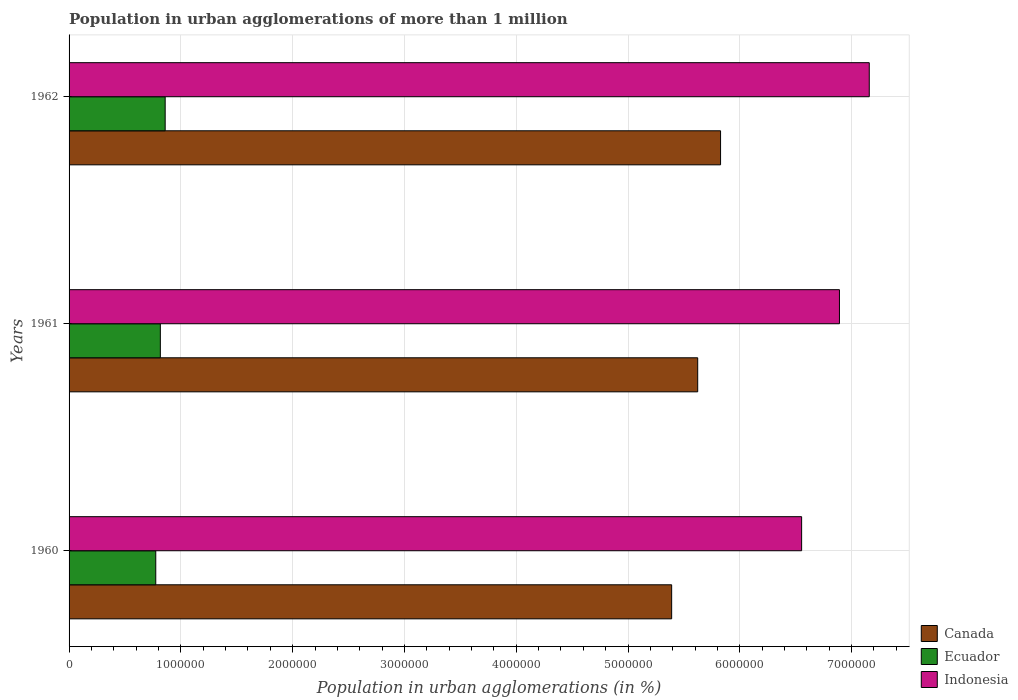How many different coloured bars are there?
Make the answer very short. 3. How many groups of bars are there?
Offer a terse response. 3. What is the label of the 1st group of bars from the top?
Offer a very short reply. 1962. In how many cases, is the number of bars for a given year not equal to the number of legend labels?
Your answer should be very brief. 0. What is the population in urban agglomerations in Indonesia in 1961?
Provide a succinct answer. 6.89e+06. Across all years, what is the maximum population in urban agglomerations in Canada?
Offer a very short reply. 5.83e+06. Across all years, what is the minimum population in urban agglomerations in Ecuador?
Offer a terse response. 7.76e+05. What is the total population in urban agglomerations in Ecuador in the graph?
Your answer should be very brief. 2.45e+06. What is the difference between the population in urban agglomerations in Canada in 1961 and that in 1962?
Your answer should be very brief. -2.04e+05. What is the difference between the population in urban agglomerations in Indonesia in 1962 and the population in urban agglomerations in Canada in 1960?
Make the answer very short. 1.77e+06. What is the average population in urban agglomerations in Indonesia per year?
Make the answer very short. 6.87e+06. In the year 1962, what is the difference between the population in urban agglomerations in Canada and population in urban agglomerations in Ecuador?
Your response must be concise. 4.97e+06. What is the ratio of the population in urban agglomerations in Indonesia in 1960 to that in 1961?
Ensure brevity in your answer.  0.95. What is the difference between the highest and the second highest population in urban agglomerations in Ecuador?
Ensure brevity in your answer.  4.32e+04. What is the difference between the highest and the lowest population in urban agglomerations in Indonesia?
Provide a short and direct response. 6.05e+05. In how many years, is the population in urban agglomerations in Indonesia greater than the average population in urban agglomerations in Indonesia taken over all years?
Provide a short and direct response. 2. How many bars are there?
Keep it short and to the point. 9. Are all the bars in the graph horizontal?
Give a very brief answer. Yes. How many years are there in the graph?
Your response must be concise. 3. What is the difference between two consecutive major ticks on the X-axis?
Give a very brief answer. 1.00e+06. Does the graph contain any zero values?
Provide a short and direct response. No. Does the graph contain grids?
Your answer should be compact. Yes. How many legend labels are there?
Offer a very short reply. 3. How are the legend labels stacked?
Keep it short and to the point. Vertical. What is the title of the graph?
Provide a succinct answer. Population in urban agglomerations of more than 1 million. Does "Bulgaria" appear as one of the legend labels in the graph?
Your response must be concise. No. What is the label or title of the X-axis?
Offer a very short reply. Population in urban agglomerations (in %). What is the Population in urban agglomerations (in %) in Canada in 1960?
Offer a very short reply. 5.39e+06. What is the Population in urban agglomerations (in %) in Ecuador in 1960?
Keep it short and to the point. 7.76e+05. What is the Population in urban agglomerations (in %) of Indonesia in 1960?
Your answer should be compact. 6.55e+06. What is the Population in urban agglomerations (in %) of Canada in 1961?
Ensure brevity in your answer.  5.62e+06. What is the Population in urban agglomerations (in %) of Ecuador in 1961?
Offer a terse response. 8.16e+05. What is the Population in urban agglomerations (in %) of Indonesia in 1961?
Ensure brevity in your answer.  6.89e+06. What is the Population in urban agglomerations (in %) in Canada in 1962?
Your answer should be very brief. 5.83e+06. What is the Population in urban agglomerations (in %) in Ecuador in 1962?
Offer a terse response. 8.60e+05. What is the Population in urban agglomerations (in %) in Indonesia in 1962?
Make the answer very short. 7.16e+06. Across all years, what is the maximum Population in urban agglomerations (in %) in Canada?
Give a very brief answer. 5.83e+06. Across all years, what is the maximum Population in urban agglomerations (in %) in Ecuador?
Offer a very short reply. 8.60e+05. Across all years, what is the maximum Population in urban agglomerations (in %) in Indonesia?
Provide a succinct answer. 7.16e+06. Across all years, what is the minimum Population in urban agglomerations (in %) in Canada?
Make the answer very short. 5.39e+06. Across all years, what is the minimum Population in urban agglomerations (in %) in Ecuador?
Ensure brevity in your answer.  7.76e+05. Across all years, what is the minimum Population in urban agglomerations (in %) in Indonesia?
Keep it short and to the point. 6.55e+06. What is the total Population in urban agglomerations (in %) in Canada in the graph?
Provide a succinct answer. 1.68e+07. What is the total Population in urban agglomerations (in %) of Ecuador in the graph?
Your answer should be very brief. 2.45e+06. What is the total Population in urban agglomerations (in %) in Indonesia in the graph?
Ensure brevity in your answer.  2.06e+07. What is the difference between the Population in urban agglomerations (in %) in Canada in 1960 and that in 1961?
Provide a short and direct response. -2.33e+05. What is the difference between the Population in urban agglomerations (in %) in Ecuador in 1960 and that in 1961?
Your answer should be compact. -4.09e+04. What is the difference between the Population in urban agglomerations (in %) of Indonesia in 1960 and that in 1961?
Provide a short and direct response. -3.38e+05. What is the difference between the Population in urban agglomerations (in %) of Canada in 1960 and that in 1962?
Give a very brief answer. -4.37e+05. What is the difference between the Population in urban agglomerations (in %) in Ecuador in 1960 and that in 1962?
Provide a succinct answer. -8.41e+04. What is the difference between the Population in urban agglomerations (in %) of Indonesia in 1960 and that in 1962?
Your answer should be very brief. -6.05e+05. What is the difference between the Population in urban agglomerations (in %) of Canada in 1961 and that in 1962?
Make the answer very short. -2.04e+05. What is the difference between the Population in urban agglomerations (in %) of Ecuador in 1961 and that in 1962?
Provide a succinct answer. -4.32e+04. What is the difference between the Population in urban agglomerations (in %) of Indonesia in 1961 and that in 1962?
Keep it short and to the point. -2.67e+05. What is the difference between the Population in urban agglomerations (in %) of Canada in 1960 and the Population in urban agglomerations (in %) of Ecuador in 1961?
Give a very brief answer. 4.57e+06. What is the difference between the Population in urban agglomerations (in %) in Canada in 1960 and the Population in urban agglomerations (in %) in Indonesia in 1961?
Your answer should be compact. -1.50e+06. What is the difference between the Population in urban agglomerations (in %) in Ecuador in 1960 and the Population in urban agglomerations (in %) in Indonesia in 1961?
Keep it short and to the point. -6.12e+06. What is the difference between the Population in urban agglomerations (in %) of Canada in 1960 and the Population in urban agglomerations (in %) of Ecuador in 1962?
Keep it short and to the point. 4.53e+06. What is the difference between the Population in urban agglomerations (in %) in Canada in 1960 and the Population in urban agglomerations (in %) in Indonesia in 1962?
Give a very brief answer. -1.77e+06. What is the difference between the Population in urban agglomerations (in %) in Ecuador in 1960 and the Population in urban agglomerations (in %) in Indonesia in 1962?
Your response must be concise. -6.38e+06. What is the difference between the Population in urban agglomerations (in %) of Canada in 1961 and the Population in urban agglomerations (in %) of Ecuador in 1962?
Provide a succinct answer. 4.76e+06. What is the difference between the Population in urban agglomerations (in %) in Canada in 1961 and the Population in urban agglomerations (in %) in Indonesia in 1962?
Provide a short and direct response. -1.53e+06. What is the difference between the Population in urban agglomerations (in %) in Ecuador in 1961 and the Population in urban agglomerations (in %) in Indonesia in 1962?
Offer a terse response. -6.34e+06. What is the average Population in urban agglomerations (in %) of Canada per year?
Make the answer very short. 5.61e+06. What is the average Population in urban agglomerations (in %) of Ecuador per year?
Offer a terse response. 8.17e+05. What is the average Population in urban agglomerations (in %) in Indonesia per year?
Your answer should be very brief. 6.87e+06. In the year 1960, what is the difference between the Population in urban agglomerations (in %) in Canada and Population in urban agglomerations (in %) in Ecuador?
Provide a short and direct response. 4.61e+06. In the year 1960, what is the difference between the Population in urban agglomerations (in %) in Canada and Population in urban agglomerations (in %) in Indonesia?
Provide a short and direct response. -1.16e+06. In the year 1960, what is the difference between the Population in urban agglomerations (in %) in Ecuador and Population in urban agglomerations (in %) in Indonesia?
Your answer should be very brief. -5.78e+06. In the year 1961, what is the difference between the Population in urban agglomerations (in %) of Canada and Population in urban agglomerations (in %) of Ecuador?
Ensure brevity in your answer.  4.81e+06. In the year 1961, what is the difference between the Population in urban agglomerations (in %) of Canada and Population in urban agglomerations (in %) of Indonesia?
Your response must be concise. -1.27e+06. In the year 1961, what is the difference between the Population in urban agglomerations (in %) in Ecuador and Population in urban agglomerations (in %) in Indonesia?
Make the answer very short. -6.07e+06. In the year 1962, what is the difference between the Population in urban agglomerations (in %) of Canada and Population in urban agglomerations (in %) of Ecuador?
Your response must be concise. 4.97e+06. In the year 1962, what is the difference between the Population in urban agglomerations (in %) in Canada and Population in urban agglomerations (in %) in Indonesia?
Ensure brevity in your answer.  -1.33e+06. In the year 1962, what is the difference between the Population in urban agglomerations (in %) of Ecuador and Population in urban agglomerations (in %) of Indonesia?
Your response must be concise. -6.30e+06. What is the ratio of the Population in urban agglomerations (in %) of Canada in 1960 to that in 1961?
Offer a terse response. 0.96. What is the ratio of the Population in urban agglomerations (in %) of Ecuador in 1960 to that in 1961?
Your response must be concise. 0.95. What is the ratio of the Population in urban agglomerations (in %) in Indonesia in 1960 to that in 1961?
Your answer should be very brief. 0.95. What is the ratio of the Population in urban agglomerations (in %) of Canada in 1960 to that in 1962?
Offer a very short reply. 0.92. What is the ratio of the Population in urban agglomerations (in %) in Ecuador in 1960 to that in 1962?
Give a very brief answer. 0.9. What is the ratio of the Population in urban agglomerations (in %) of Indonesia in 1960 to that in 1962?
Offer a terse response. 0.92. What is the ratio of the Population in urban agglomerations (in %) in Canada in 1961 to that in 1962?
Your answer should be compact. 0.96. What is the ratio of the Population in urban agglomerations (in %) in Ecuador in 1961 to that in 1962?
Provide a succinct answer. 0.95. What is the ratio of the Population in urban agglomerations (in %) of Indonesia in 1961 to that in 1962?
Provide a short and direct response. 0.96. What is the difference between the highest and the second highest Population in urban agglomerations (in %) of Canada?
Give a very brief answer. 2.04e+05. What is the difference between the highest and the second highest Population in urban agglomerations (in %) of Ecuador?
Offer a very short reply. 4.32e+04. What is the difference between the highest and the second highest Population in urban agglomerations (in %) in Indonesia?
Your answer should be very brief. 2.67e+05. What is the difference between the highest and the lowest Population in urban agglomerations (in %) in Canada?
Your response must be concise. 4.37e+05. What is the difference between the highest and the lowest Population in urban agglomerations (in %) in Ecuador?
Your answer should be very brief. 8.41e+04. What is the difference between the highest and the lowest Population in urban agglomerations (in %) of Indonesia?
Offer a terse response. 6.05e+05. 